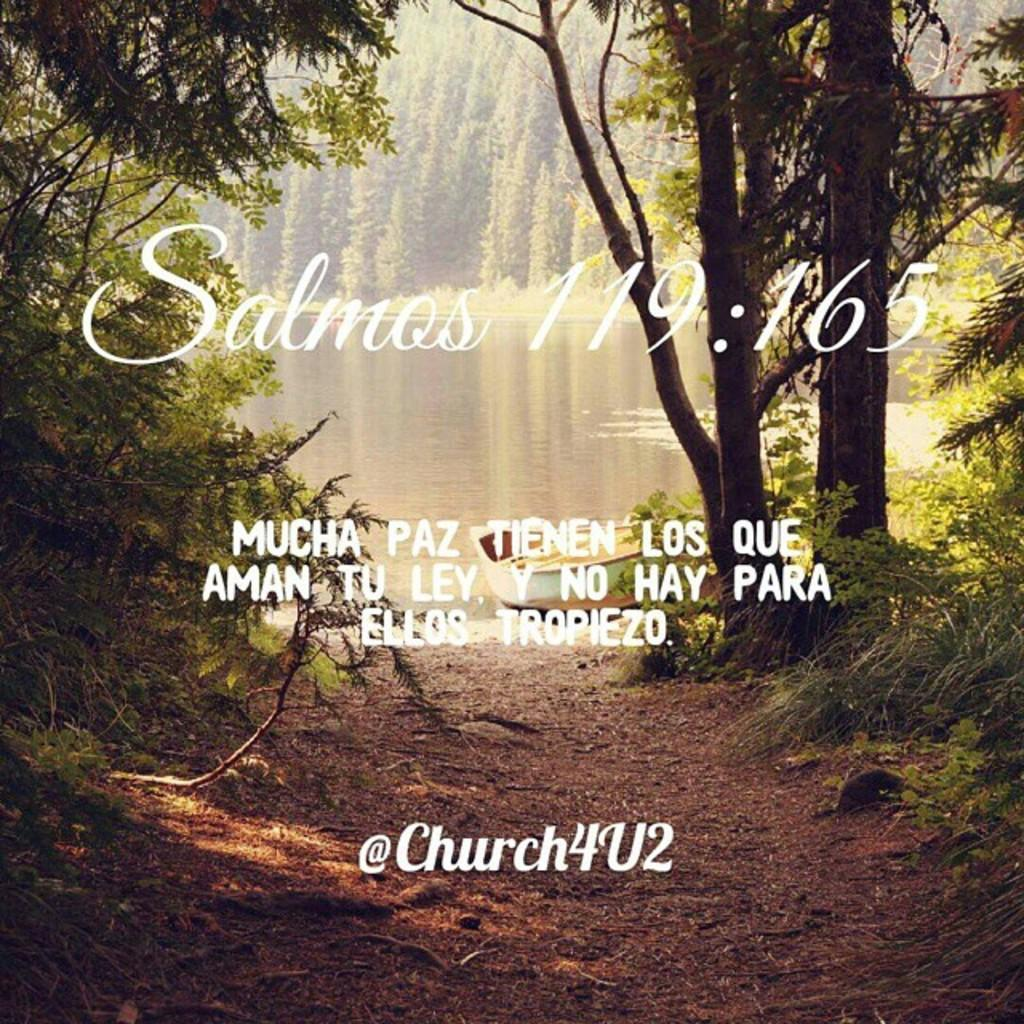What is the main feature of the image? There is text printed in the center of the image. What can be seen in the background of the image? There are trees in the background of the image. What is present at the bottom of the image? There is soil at the bottom of the image. What else is visible in the image besides the text and trees? There is water visible in the image. What type of sock is being used to create the design in the image? There is no sock or design present in the image; it features text, trees, soil, and water. 